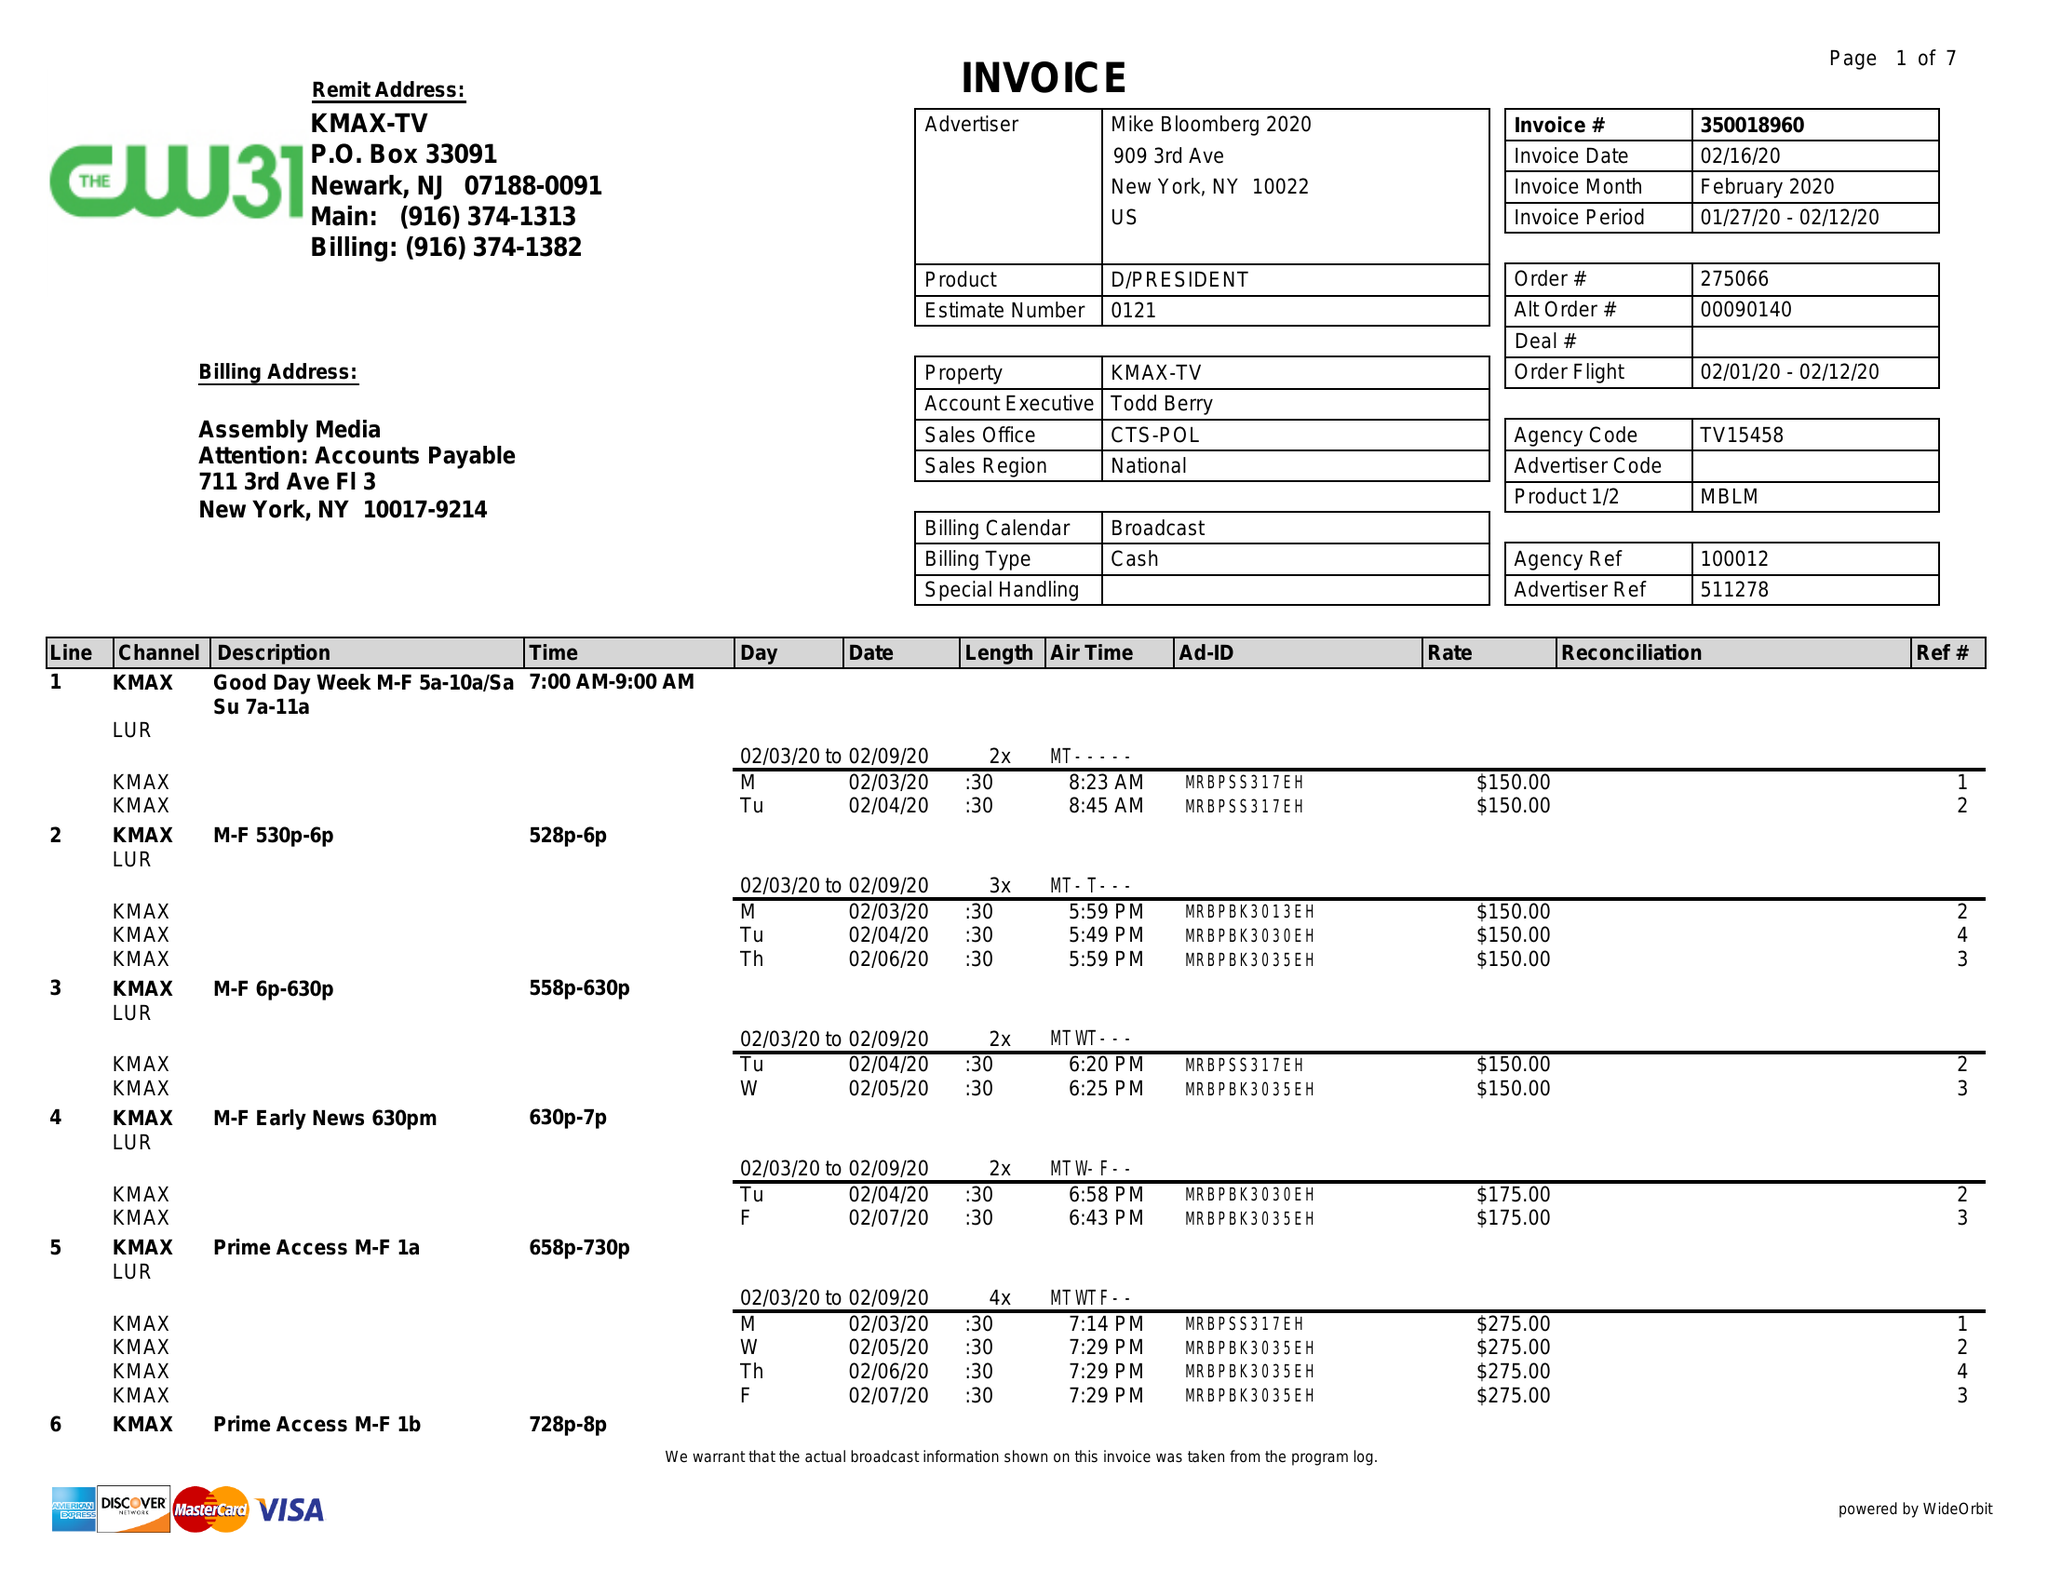What is the value for the advertiser?
Answer the question using a single word or phrase. MIKE BLOOMBERG 2020 